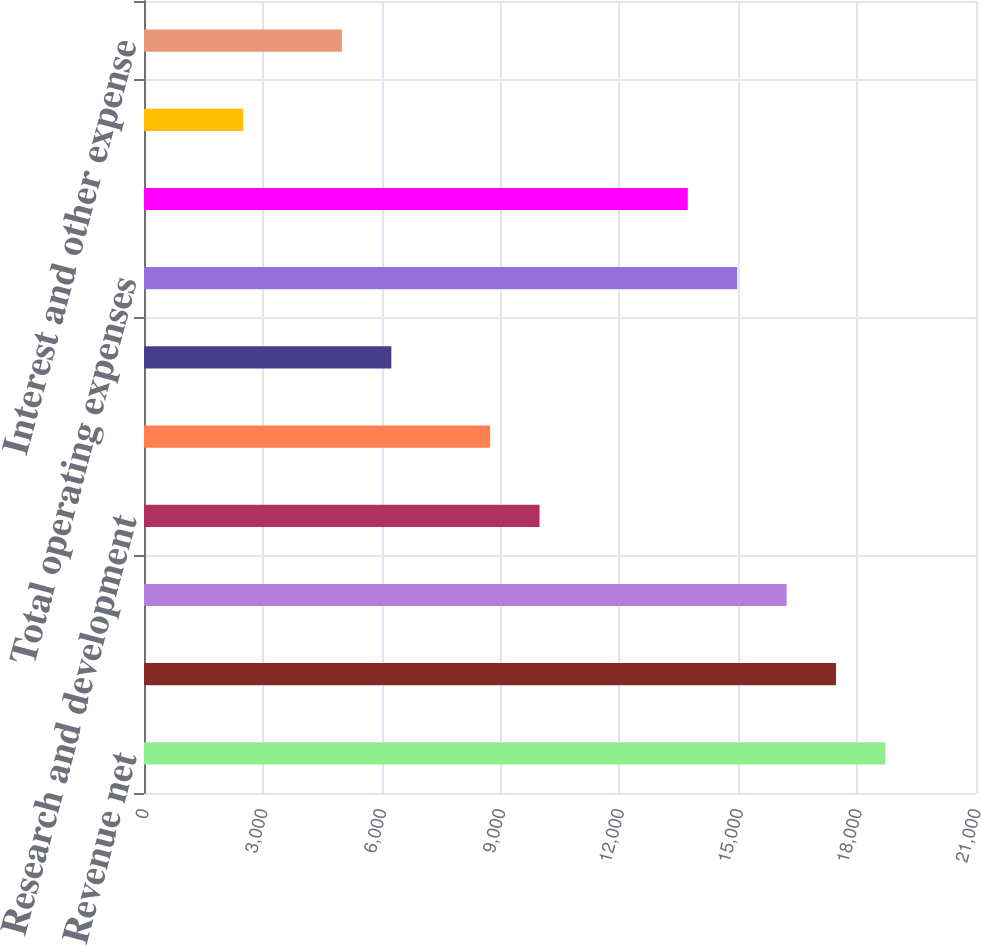Convert chart. <chart><loc_0><loc_0><loc_500><loc_500><bar_chart><fcel>Revenue net<fcel>Cost of revenue<fcel>Gross profit<fcel>Research and development<fcel>Selling general and<fcel>Employee termination asset<fcel>Total operating expenses<fcel>Operating income<fcel>Interest and other income<fcel>Interest and other expense<nl><fcel>18713.7<fcel>17466.5<fcel>16219.4<fcel>9983.7<fcel>8736.56<fcel>6242.28<fcel>14972.3<fcel>13725.1<fcel>2500.86<fcel>4995.14<nl></chart> 